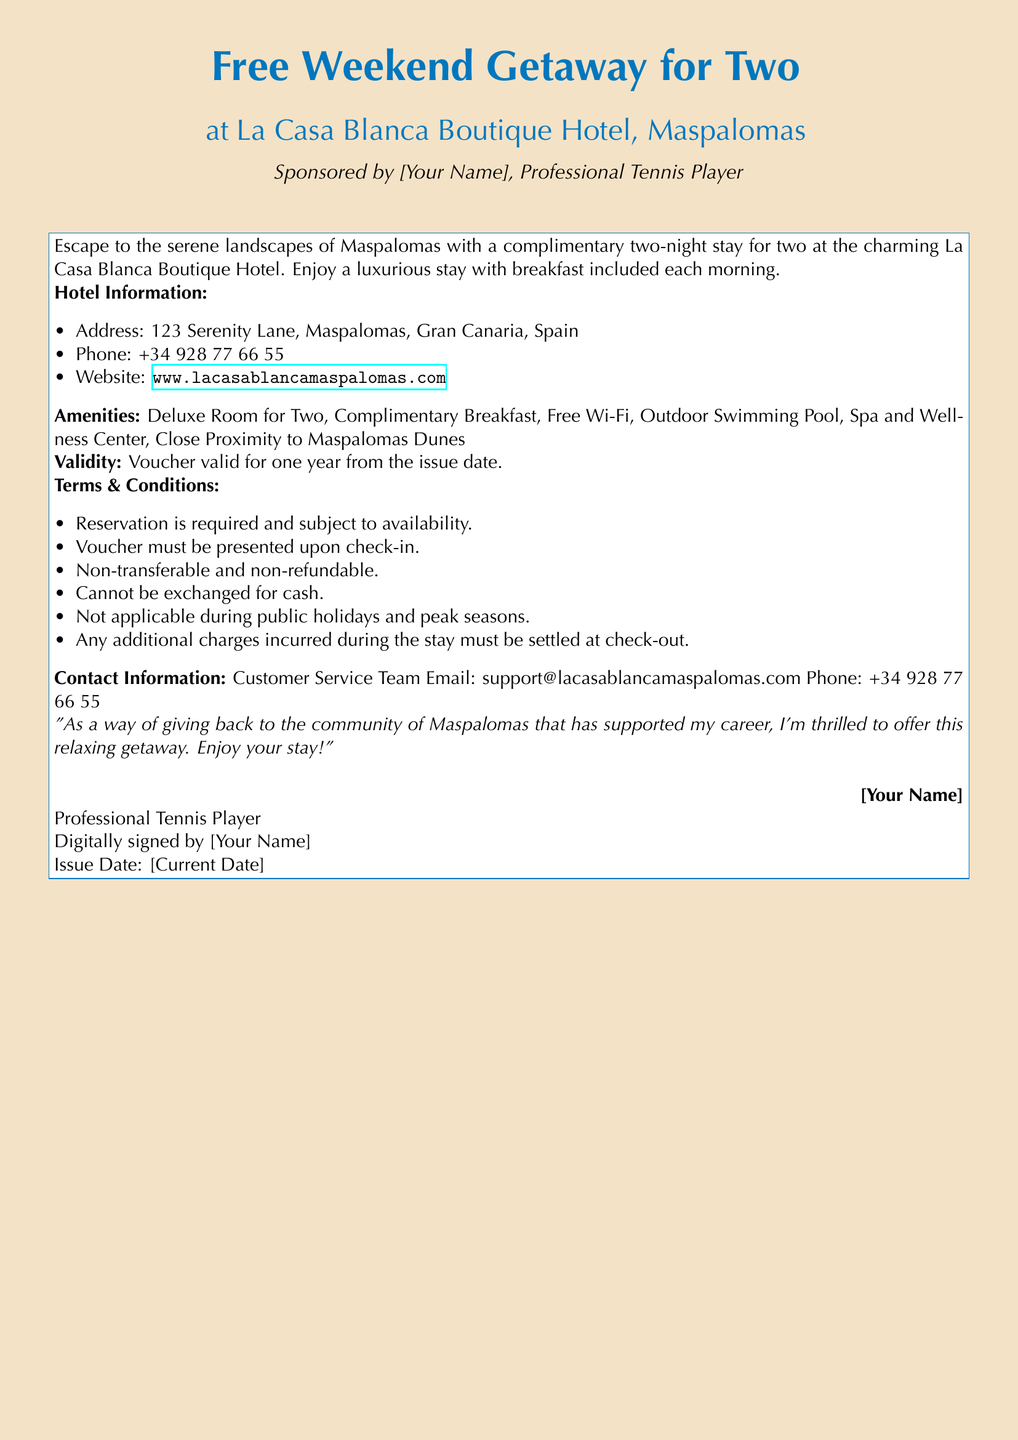What is the name of the hotel? The document explicitly states the name of the hotel as "La Casa Blanca Boutique Hotel."
Answer: La Casa Blanca Boutique Hotel What amenities are included? The document lists several amenities, including "Deluxe Room for Two, Complimentary Breakfast, Free Wi-Fi, Outdoor Swimming Pool, Spa and Wellness Center."
Answer: Deluxe Room for Two, Complimentary Breakfast, Free Wi-Fi, Outdoor Swimming Pool, Spa and Wellness Center How long is the voucher valid? The document mentions that the voucher is valid for one year from the issue date.
Answer: One year What is the phone number for the hotel? The document provides the hotel's phone number as "+34 928 77 66 55."
Answer: +34 928 77 66 55 Is the voucher transferable? According to the terms and conditions specified in the document, the voucher is "non-transferable."
Answer: Non-transferable What must be presented upon check-in? The document states that the "voucher must be presented upon check-in."
Answer: Voucher Who is sponsoring the getaway? The document mentions that the getaway is sponsored by "[Your Name], Professional Tennis Player."
Answer: [Your Name] What is explicitly included in the stay? The document states that the complimentary stay includes "breakfast included each morning."
Answer: Breakfast included each morning Are additional charges applicable? The document states that "any additional charges incurred during the stay must be settled at check-out."
Answer: Yes 